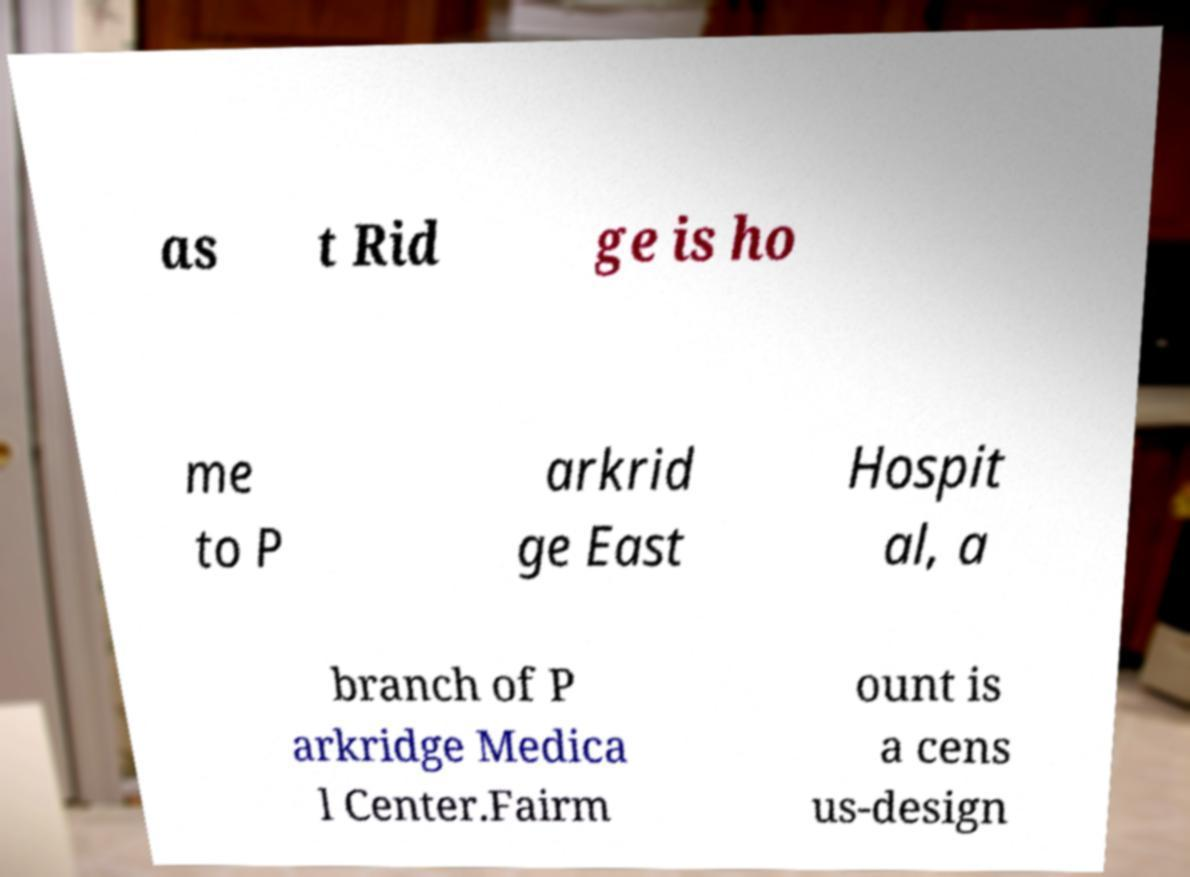Can you accurately transcribe the text from the provided image for me? as t Rid ge is ho me to P arkrid ge East Hospit al, a branch of P arkridge Medica l Center.Fairm ount is a cens us-design 